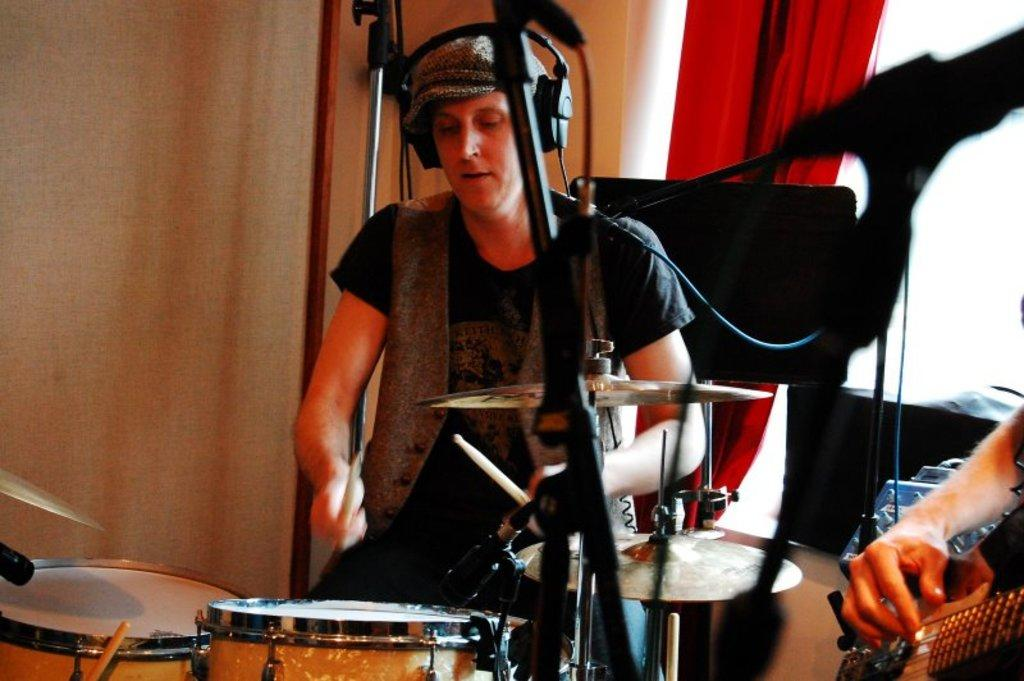What activity is the person on the left side of the image engaged in? The person on the left side of the image is playing drums. What instrument is the person on the right side of the image playing? The person on the right side of the image is playing guitar. Can you describe the position of the person playing guitar in the image? The person playing guitar is on the right side of the image. What can be seen in the background of the image? There is a red curtain in the background of the image. What nation is the person playing drums from, based on the image? The image does not provide any information about the person's nationality, so it cannot be determined from the image. 